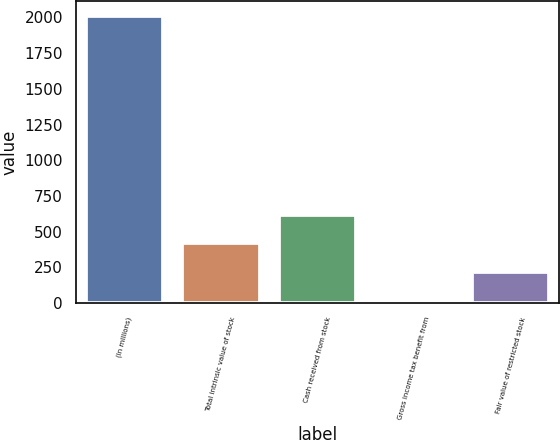<chart> <loc_0><loc_0><loc_500><loc_500><bar_chart><fcel>(In millions)<fcel>Total intrinsic value of stock<fcel>Cash received from stock<fcel>Gross income tax benefit from<fcel>Fair value of restricted stock<nl><fcel>2012<fcel>418.4<fcel>617.6<fcel>20<fcel>219.2<nl></chart> 